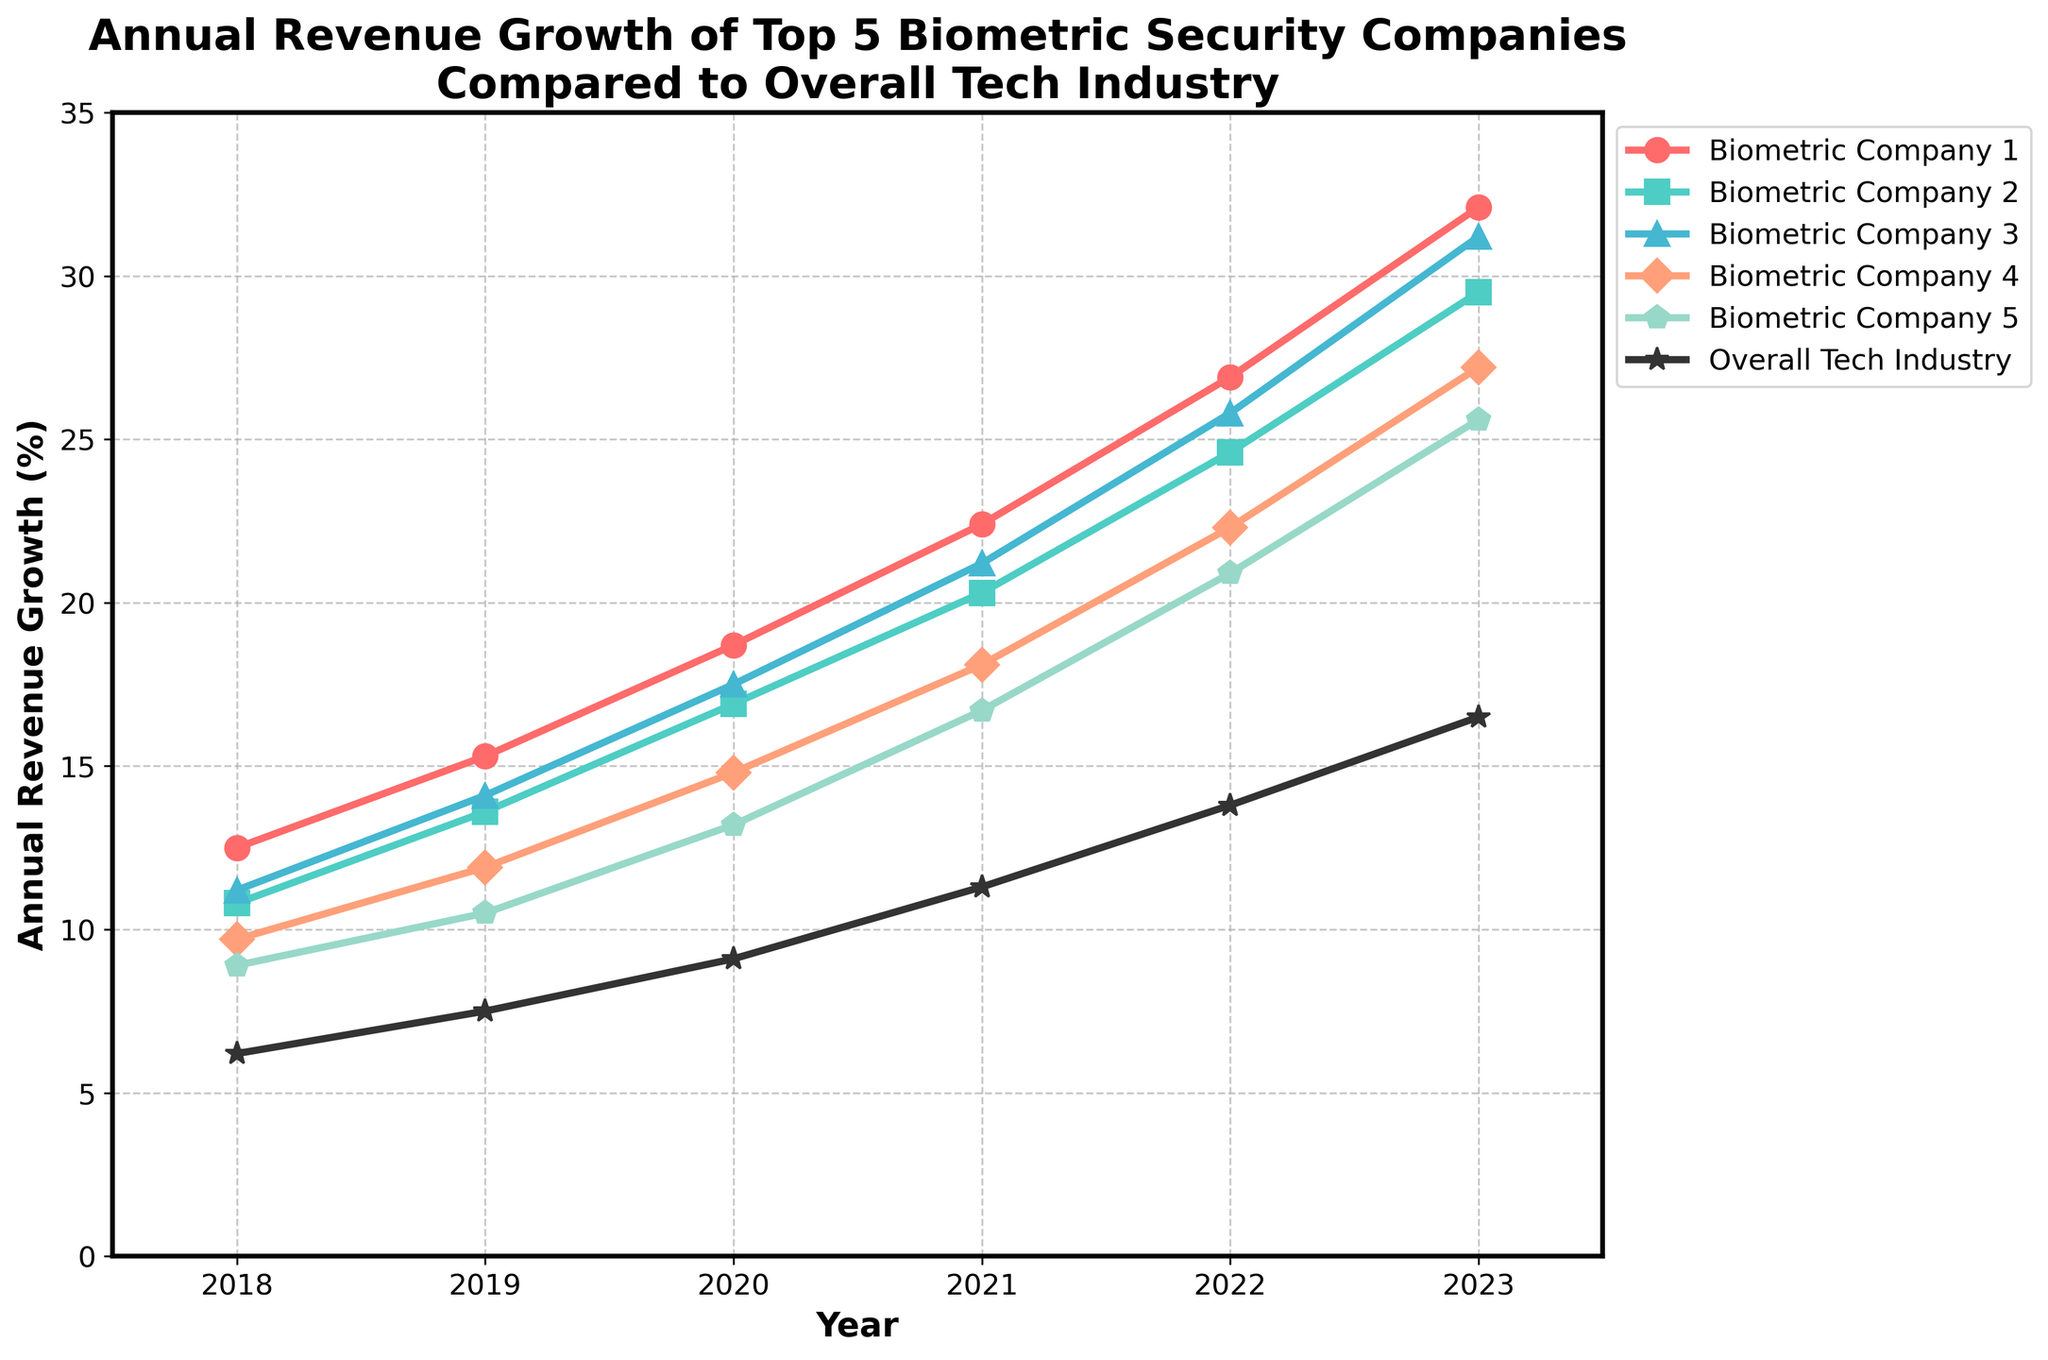Which company shows the highest annual revenue growth in 2023? The top line in 2023 corresponds to "Biometric Company 1," which has the highest value.
Answer: Biometric Company 1 How did the annual revenue growth of Biometric Company 3 change from 2018 to 2023? In 2018, Biometric Company 3 had a growth of 11.2%. By 2023, it increased to 31.2%. Therefore, the change is 31.2% - 11.2% = 20%.
Answer: Increased by 20% Which year does Biometric Company 2's revenue growth exceed Biometric Company 4's for the first time? By checking each year, in 2021, Biometric Company 2 (20.3%) exceeds Biometric Company 4 (18.1%).
Answer: 2021 What is the average annual revenue growth for Biometric Company 5 from 2018 to 2023? The values are 8.9, 10.5, 13.2, 16.7, 20.9, 25.6. Sum these values (95.8) and divide by the number of years (6).
Answer: 15.97% Compare the trend between the top-performing biometric company and the overall tech industry. Biometric Company 1 shows a steeper upward trend from 12.5% in 2018 to 32.1% in 2023, while the overall tech industry grows more gradually from 6.2% to 16.5%.
Answer: Biometric Company 1 grows faster What is the difference between Biometric Company 1’s and Biometric Company 5’s growth in 2020? The growth for Biometric Company 1 is 18.7%, and for Biometric Company 5, it is 13.2%. The difference is 18.7% - 13.2%.
Answer: 5.5% Which companies have a growth rate below the overall tech industry in 2018? Only Biometric Company 5 (8.9%) is above, while others range from 10.8% to 12.5%, which are all above 6.2% (overall tech industry).
Answer: None Identify the pattern for Biometric Company 4's revenue growth from 2018 to 2023. Each year shows a consistent increase: 9.7%, 11.9%, 14.8%, 18.1%, 22.3%, 27.2%. The company's growth increases steadily over time.
Answer: Steady increase In which years does Biometric Company 1 outperform Biometric Company 2 by more than 5%? In 2023, Biometric Company 1 (32.1%) outperforms Biometric Company 2 (29.5%) by 2.6%. Only in 2019 (15.3% - 13.6% = 1.7%), do they outpace by less than 5%, while the gaps are minimal.
Answer: None 